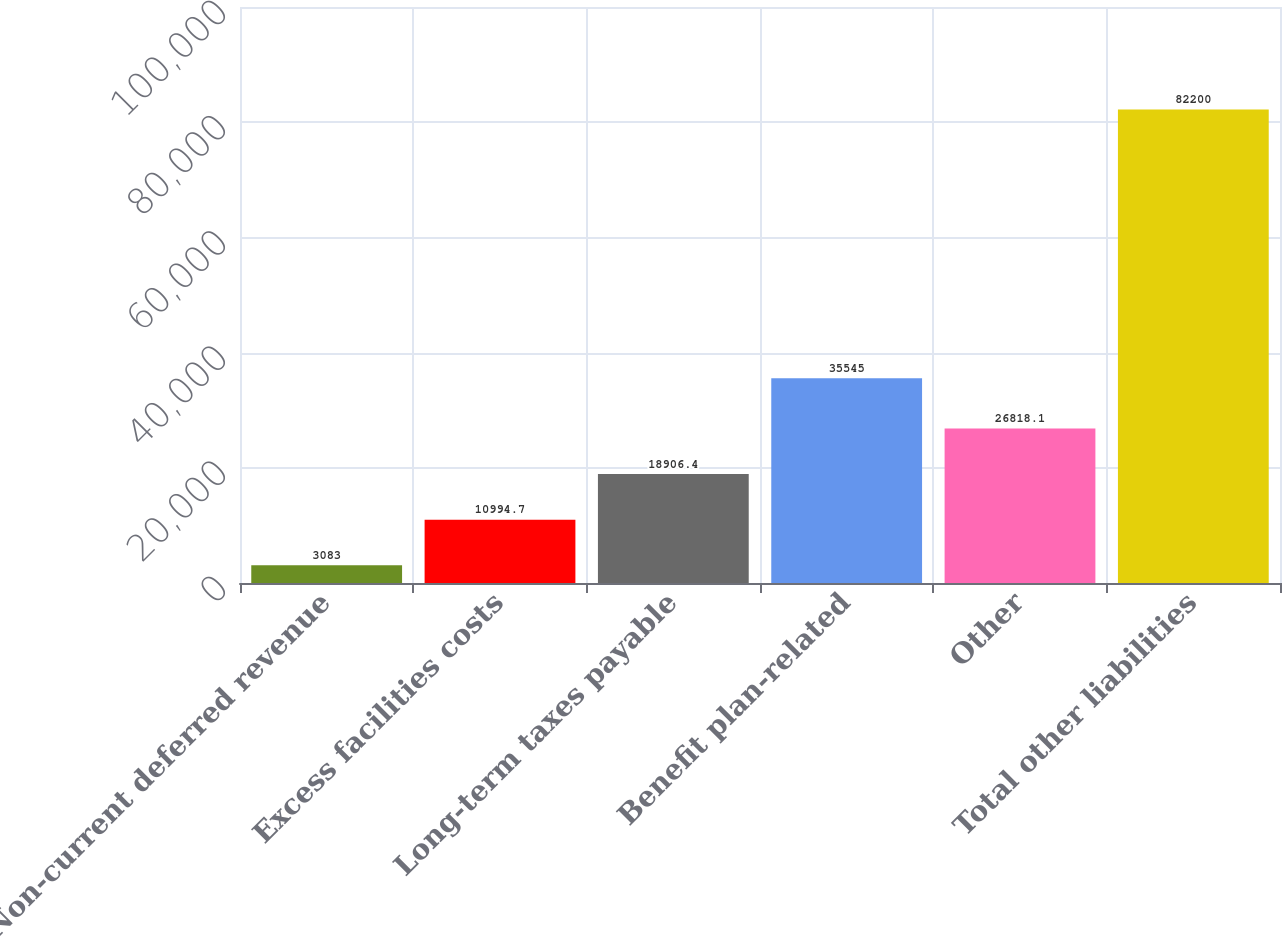Convert chart to OTSL. <chart><loc_0><loc_0><loc_500><loc_500><bar_chart><fcel>Non-current deferred revenue<fcel>Excess facilities costs<fcel>Long-term taxes payable<fcel>Benefit plan-related<fcel>Other<fcel>Total other liabilities<nl><fcel>3083<fcel>10994.7<fcel>18906.4<fcel>35545<fcel>26818.1<fcel>82200<nl></chart> 